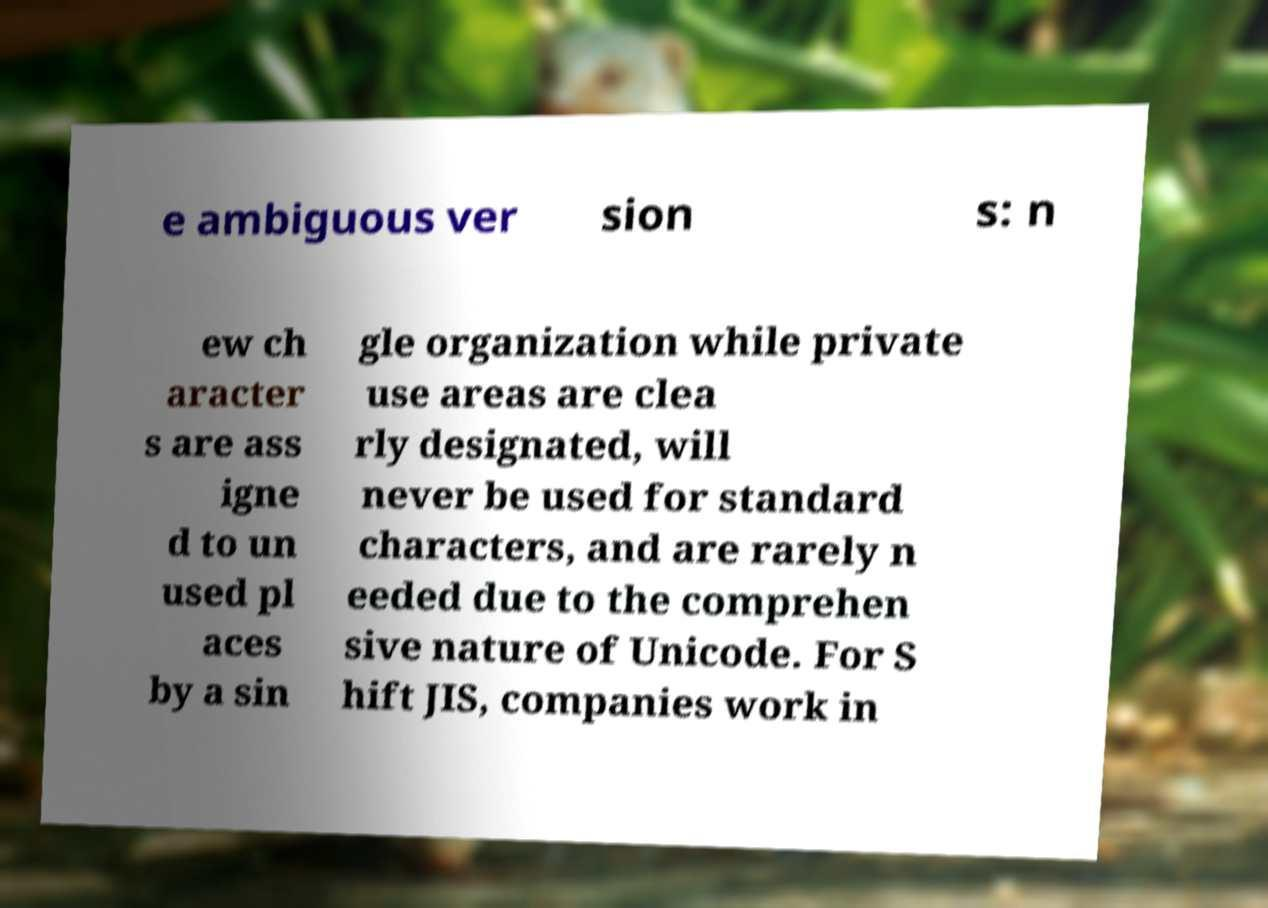What messages or text are displayed in this image? I need them in a readable, typed format. e ambiguous ver sion s: n ew ch aracter s are ass igne d to un used pl aces by a sin gle organization while private use areas are clea rly designated, will never be used for standard characters, and are rarely n eeded due to the comprehen sive nature of Unicode. For S hift JIS, companies work in 